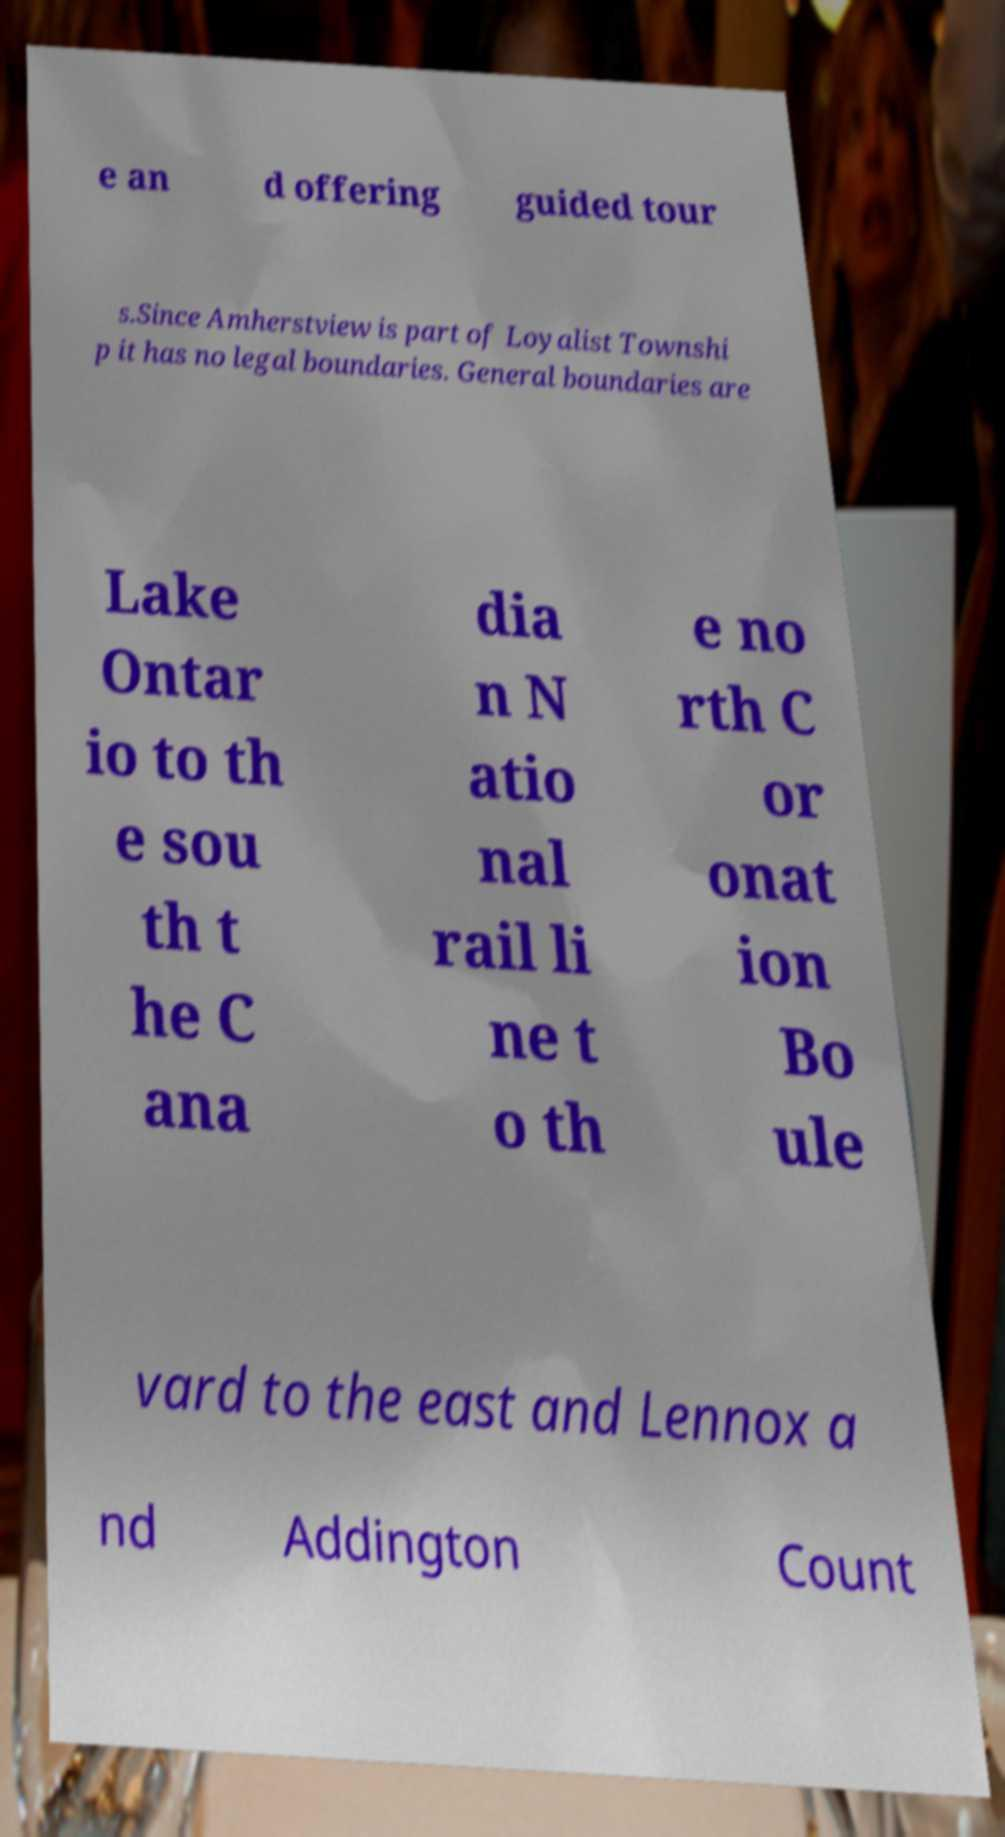There's text embedded in this image that I need extracted. Can you transcribe it verbatim? e an d offering guided tour s.Since Amherstview is part of Loyalist Townshi p it has no legal boundaries. General boundaries are Lake Ontar io to th e sou th t he C ana dia n N atio nal rail li ne t o th e no rth C or onat ion Bo ule vard to the east and Lennox a nd Addington Count 